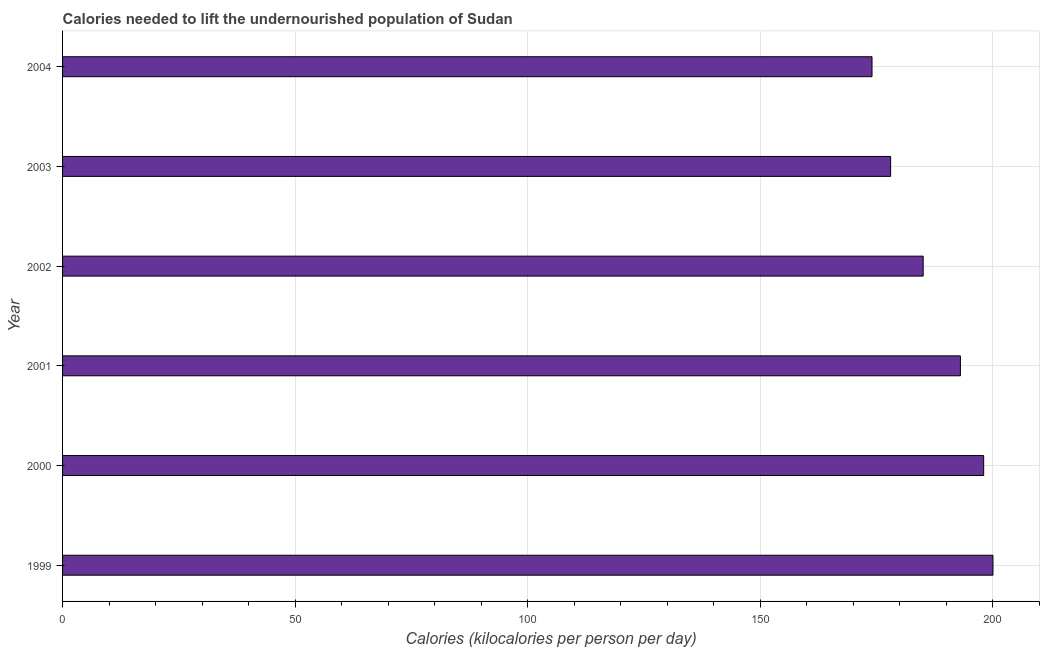Does the graph contain any zero values?
Your answer should be compact. No. Does the graph contain grids?
Offer a terse response. Yes. What is the title of the graph?
Offer a very short reply. Calories needed to lift the undernourished population of Sudan. What is the label or title of the X-axis?
Your response must be concise. Calories (kilocalories per person per day). What is the label or title of the Y-axis?
Offer a terse response. Year. What is the depth of food deficit in 2002?
Make the answer very short. 185. Across all years, what is the minimum depth of food deficit?
Keep it short and to the point. 174. What is the sum of the depth of food deficit?
Provide a succinct answer. 1128. What is the average depth of food deficit per year?
Provide a short and direct response. 188. What is the median depth of food deficit?
Your response must be concise. 189. Do a majority of the years between 2000 and 2004 (inclusive) have depth of food deficit greater than 160 kilocalories?
Offer a very short reply. Yes. What is the ratio of the depth of food deficit in 1999 to that in 2004?
Provide a succinct answer. 1.15. Is the depth of food deficit in 2000 less than that in 2001?
Your response must be concise. No. In how many years, is the depth of food deficit greater than the average depth of food deficit taken over all years?
Offer a very short reply. 3. How many bars are there?
Provide a short and direct response. 6. Are the values on the major ticks of X-axis written in scientific E-notation?
Keep it short and to the point. No. What is the Calories (kilocalories per person per day) of 1999?
Keep it short and to the point. 200. What is the Calories (kilocalories per person per day) of 2000?
Keep it short and to the point. 198. What is the Calories (kilocalories per person per day) of 2001?
Make the answer very short. 193. What is the Calories (kilocalories per person per day) in 2002?
Provide a short and direct response. 185. What is the Calories (kilocalories per person per day) of 2003?
Your answer should be compact. 178. What is the Calories (kilocalories per person per day) of 2004?
Your answer should be compact. 174. What is the difference between the Calories (kilocalories per person per day) in 1999 and 2001?
Your answer should be compact. 7. What is the difference between the Calories (kilocalories per person per day) in 1999 and 2002?
Your response must be concise. 15. What is the difference between the Calories (kilocalories per person per day) in 1999 and 2004?
Offer a terse response. 26. What is the difference between the Calories (kilocalories per person per day) in 2000 and 2001?
Offer a terse response. 5. What is the difference between the Calories (kilocalories per person per day) in 2000 and 2002?
Ensure brevity in your answer.  13. What is the difference between the Calories (kilocalories per person per day) in 2000 and 2003?
Ensure brevity in your answer.  20. What is the difference between the Calories (kilocalories per person per day) in 2000 and 2004?
Give a very brief answer. 24. What is the difference between the Calories (kilocalories per person per day) in 2001 and 2003?
Provide a succinct answer. 15. What is the difference between the Calories (kilocalories per person per day) in 2001 and 2004?
Provide a succinct answer. 19. What is the difference between the Calories (kilocalories per person per day) in 2003 and 2004?
Keep it short and to the point. 4. What is the ratio of the Calories (kilocalories per person per day) in 1999 to that in 2000?
Your response must be concise. 1.01. What is the ratio of the Calories (kilocalories per person per day) in 1999 to that in 2001?
Provide a succinct answer. 1.04. What is the ratio of the Calories (kilocalories per person per day) in 1999 to that in 2002?
Provide a succinct answer. 1.08. What is the ratio of the Calories (kilocalories per person per day) in 1999 to that in 2003?
Your response must be concise. 1.12. What is the ratio of the Calories (kilocalories per person per day) in 1999 to that in 2004?
Provide a succinct answer. 1.15. What is the ratio of the Calories (kilocalories per person per day) in 2000 to that in 2002?
Ensure brevity in your answer.  1.07. What is the ratio of the Calories (kilocalories per person per day) in 2000 to that in 2003?
Your answer should be very brief. 1.11. What is the ratio of the Calories (kilocalories per person per day) in 2000 to that in 2004?
Offer a very short reply. 1.14. What is the ratio of the Calories (kilocalories per person per day) in 2001 to that in 2002?
Keep it short and to the point. 1.04. What is the ratio of the Calories (kilocalories per person per day) in 2001 to that in 2003?
Your answer should be very brief. 1.08. What is the ratio of the Calories (kilocalories per person per day) in 2001 to that in 2004?
Give a very brief answer. 1.11. What is the ratio of the Calories (kilocalories per person per day) in 2002 to that in 2003?
Provide a succinct answer. 1.04. What is the ratio of the Calories (kilocalories per person per day) in 2002 to that in 2004?
Ensure brevity in your answer.  1.06. 